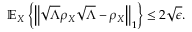<formula> <loc_0><loc_0><loc_500><loc_500>\mathbb { E } _ { X } \left \{ \left \| { \sqrt { \Lambda } } \rho _ { X } { \sqrt { \Lambda } } - \rho _ { X } \right \| _ { 1 } \right \} \leq 2 { \sqrt { \epsilon } } .</formula> 